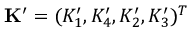<formula> <loc_0><loc_0><loc_500><loc_500>K ^ { \prime } = ( K _ { 1 } ^ { \prime } , K _ { 4 } ^ { \prime } , K _ { 2 } ^ { \prime } , K _ { 3 } ^ { \prime } ) ^ { T }</formula> 